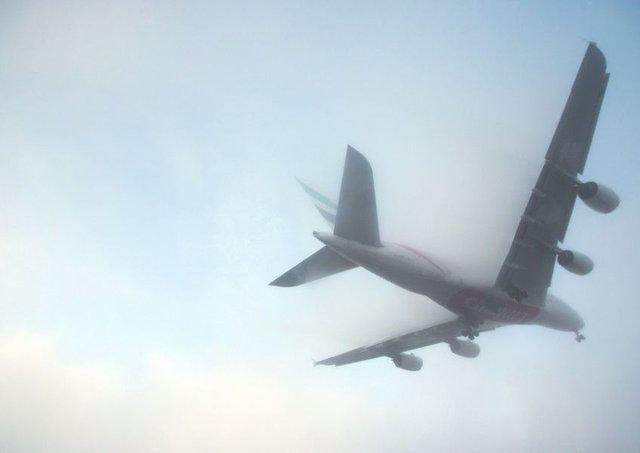What type of weather conditions can be observed in the image? The weather in the image seems to be foggy or misty, with low visibility. The diffuse light suggests an overcast sky, possibly early in the morning or during the evening. 